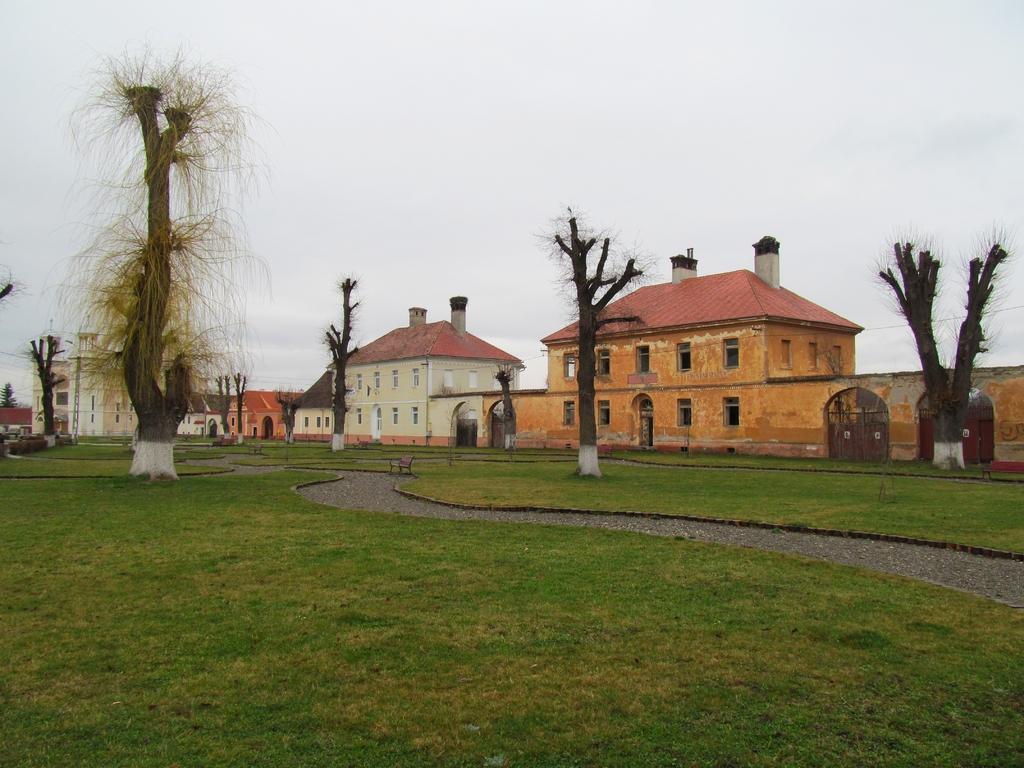In one or two sentences, can you explain what this image depicts? In the foreground of the image we can see the grass and the road. In the middle of the image we can see the houses. On the top of the image we can see the sky. 